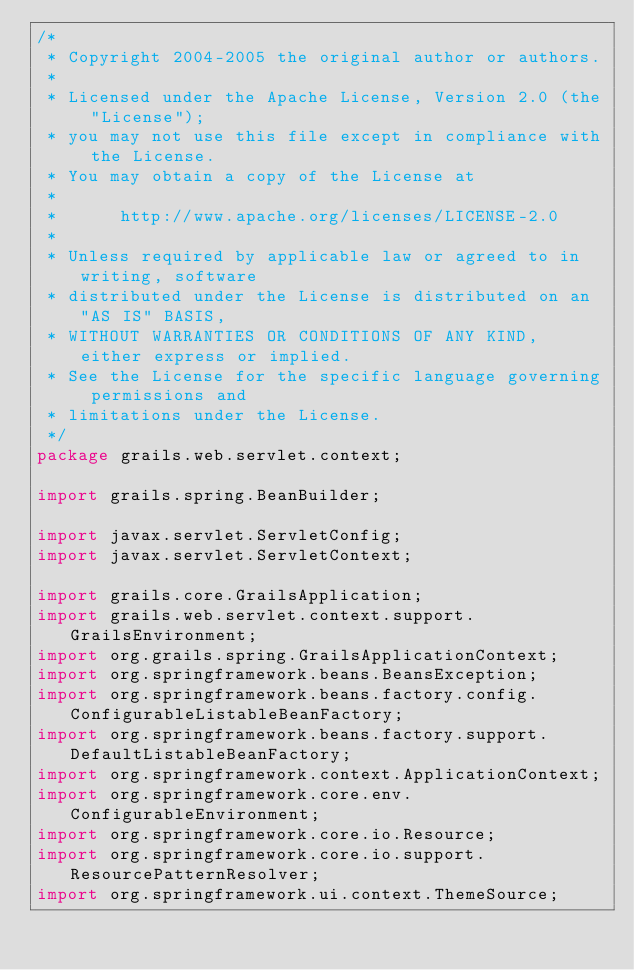Convert code to text. <code><loc_0><loc_0><loc_500><loc_500><_Java_>/*
 * Copyright 2004-2005 the original author or authors.
 *
 * Licensed under the Apache License, Version 2.0 (the "License");
 * you may not use this file except in compliance with the License.
 * You may obtain a copy of the License at
 *
 *      http://www.apache.org/licenses/LICENSE-2.0
 *
 * Unless required by applicable law or agreed to in writing, software
 * distributed under the License is distributed on an "AS IS" BASIS,
 * WITHOUT WARRANTIES OR CONDITIONS OF ANY KIND, either express or implied.
 * See the License for the specific language governing permissions and
 * limitations under the License.
 */
package grails.web.servlet.context;

import grails.spring.BeanBuilder;

import javax.servlet.ServletConfig;
import javax.servlet.ServletContext;

import grails.core.GrailsApplication;
import grails.web.servlet.context.support.GrailsEnvironment;
import org.grails.spring.GrailsApplicationContext;
import org.springframework.beans.BeansException;
import org.springframework.beans.factory.config.ConfigurableListableBeanFactory;
import org.springframework.beans.factory.support.DefaultListableBeanFactory;
import org.springframework.context.ApplicationContext;
import org.springframework.core.env.ConfigurableEnvironment;
import org.springframework.core.io.Resource;
import org.springframework.core.io.support.ResourcePatternResolver;
import org.springframework.ui.context.ThemeSource;</code> 